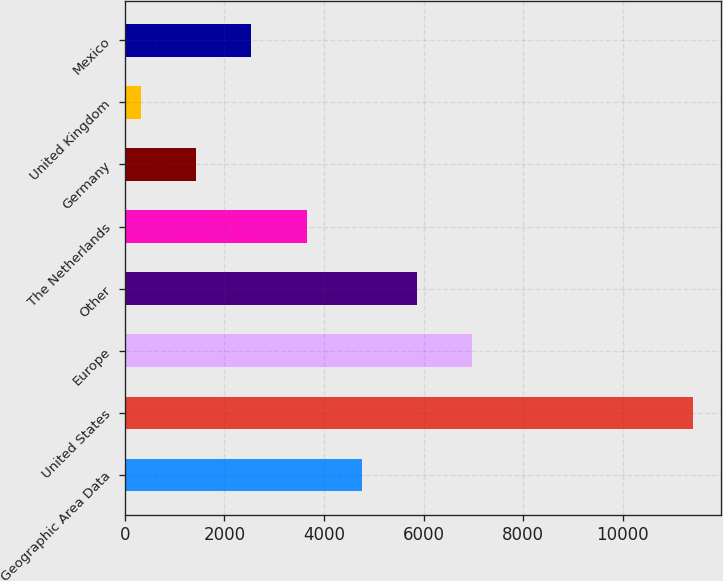<chart> <loc_0><loc_0><loc_500><loc_500><bar_chart><fcel>Geographic Area Data<fcel>United States<fcel>Europe<fcel>Other<fcel>The Netherlands<fcel>Germany<fcel>United Kingdom<fcel>Mexico<nl><fcel>4756.1<fcel>11408.3<fcel>6973.5<fcel>5864.8<fcel>3647.4<fcel>1430<fcel>321.3<fcel>2538.7<nl></chart> 